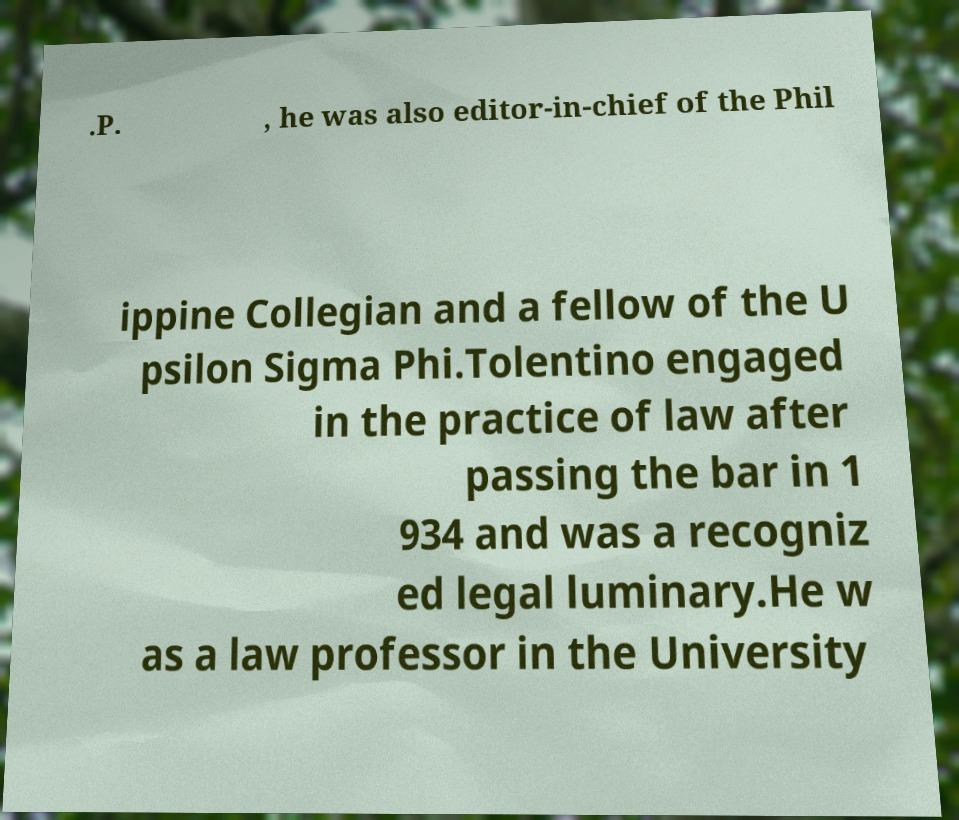Could you assist in decoding the text presented in this image and type it out clearly? .P. , he was also editor-in-chief of the Phil ippine Collegian and a fellow of the U psilon Sigma Phi.Tolentino engaged in the practice of law after passing the bar in 1 934 and was a recogniz ed legal luminary.He w as a law professor in the University 